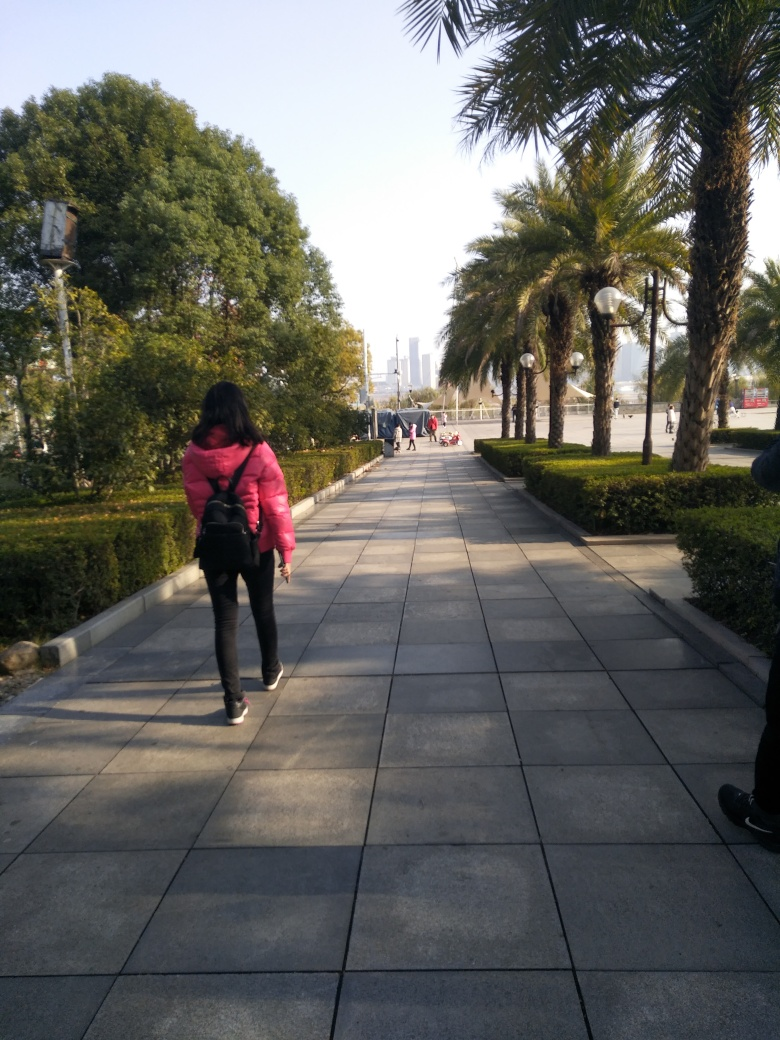What is the overall clarity of this image? The image clarity is generally acceptable, with the foreground and midground details, including the pedestrian pathway and surrounding trees, being relatively sharp and discernible. However, the distant background, including the buildings, appears slightly hazy, possibly due to atmospheric conditions or lens focus, which prevents the clarity from being excellent. 